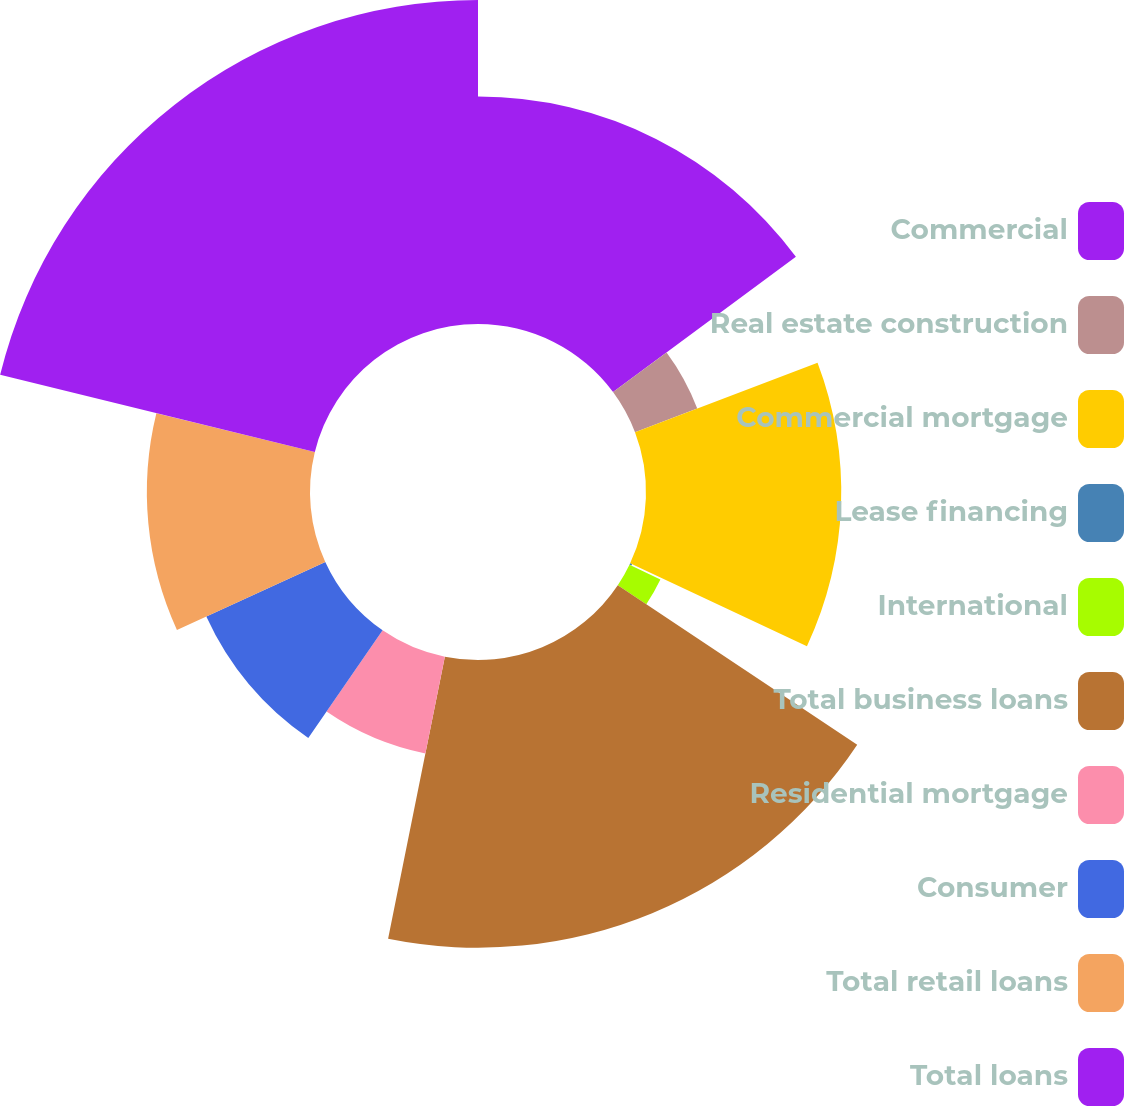Convert chart to OTSL. <chart><loc_0><loc_0><loc_500><loc_500><pie_chart><fcel>Commercial<fcel>Real estate construction<fcel>Commercial mortgage<fcel>Lease financing<fcel>International<fcel>Total business loans<fcel>Residential mortgage<fcel>Consumer<fcel>Total retail loans<fcel>Total loans<nl><fcel>14.86%<fcel>4.35%<fcel>12.76%<fcel>0.14%<fcel>2.24%<fcel>18.8%<fcel>6.45%<fcel>8.55%<fcel>10.66%<fcel>21.17%<nl></chart> 